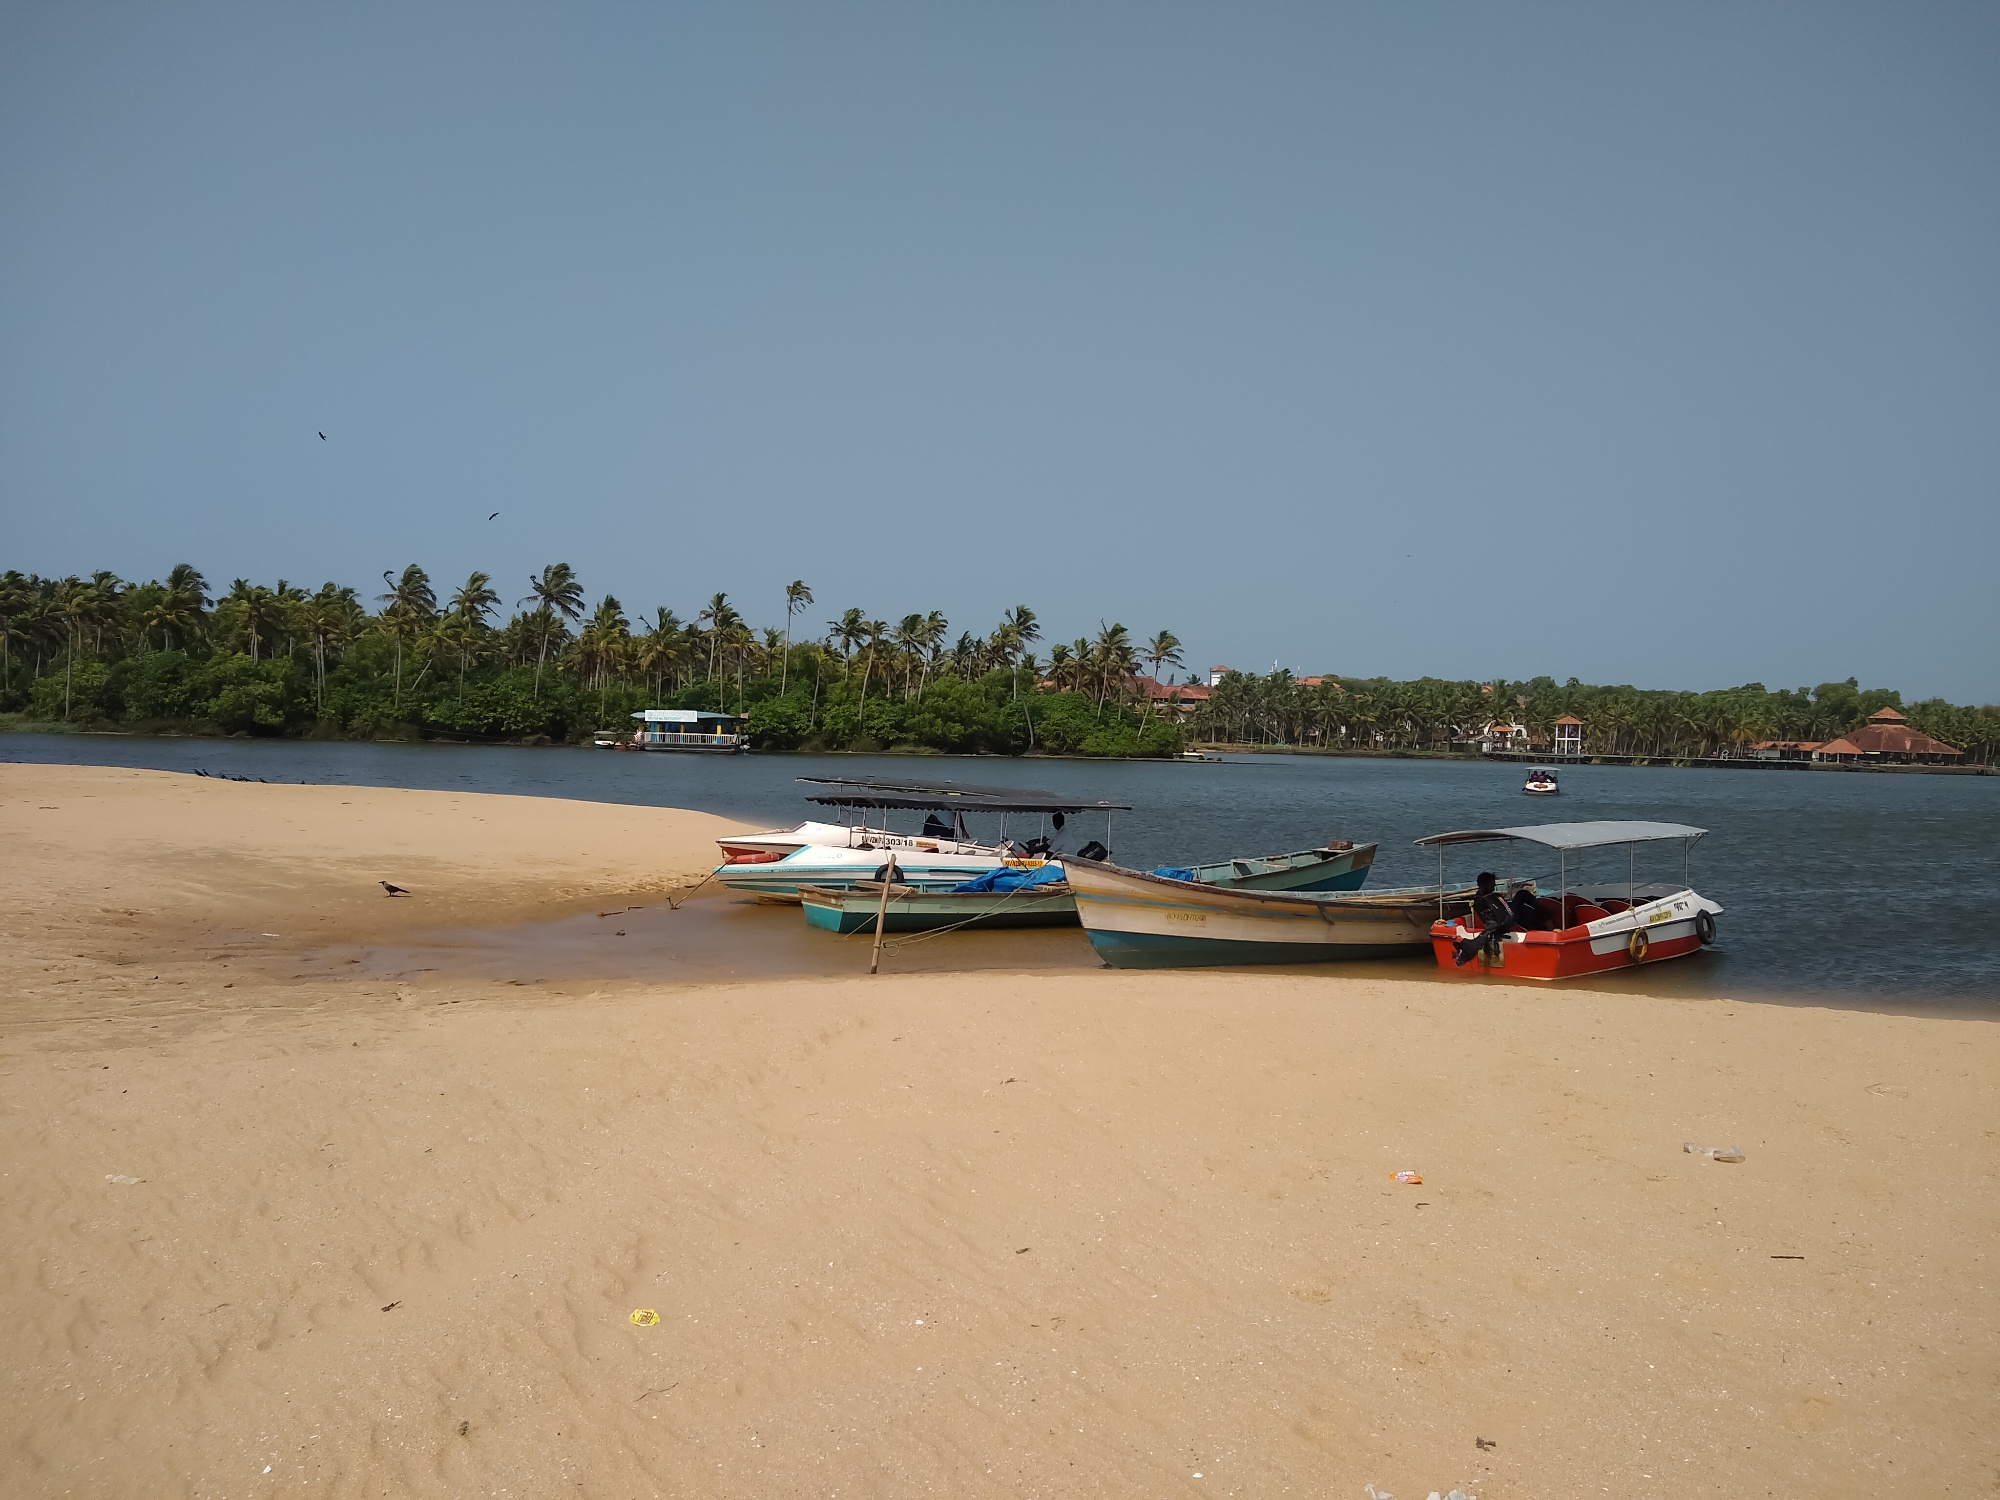What do you think is going on in this snapshot? The image portrays a calm and picturesque beach setting in India. The golden sandy shore is home to several colorful wooden boats, illustrating the local fishing culture. These boats, either in use or awaiting their next voyage, add vibrant colors to the serene scene. The tranquil water gently laps the shore under a clear blue sky, reflecting the calmness of the environment. Palm trees form a lush green fringe along the beach, enhancing the tropical allure of the locale. In the background, some structures can be seen nestled amongst the greenery, indicating a small coastal community. This perspective, looking from the shore outward, invites the viewer to feel the peaceful and relaxing ambiance of this coastal paradise. 